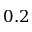<formula> <loc_0><loc_0><loc_500><loc_500>0 . 2</formula> 